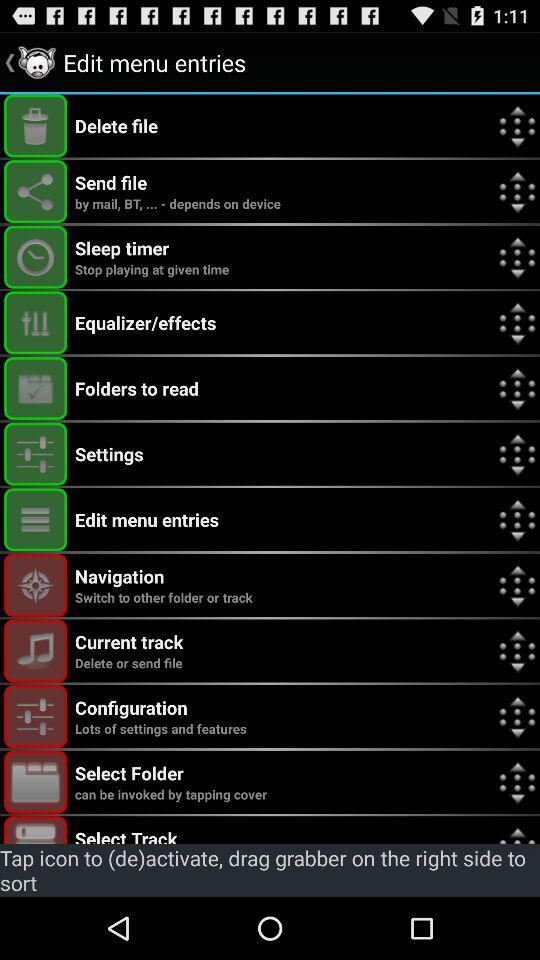What's the use of Sleep timer?
When the provided information is insufficient, respond with <no answer>. <no answer> 